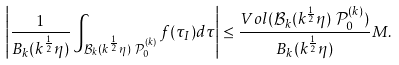Convert formula to latex. <formula><loc_0><loc_0><loc_500><loc_500>& \left | \frac { 1 } { B _ { k } ( k ^ { \frac { 1 } { 2 } } \eta ) } \int _ { \mathcal { B } _ { k } ( k ^ { \frac { 1 } { 2 } } \eta ) \ \mathcal { P } _ { 0 } ^ { ( k ) } } f ( \tau _ { I } ) d \tau \right | \leq \frac { V o l ( \mathcal { B } _ { k } ( k ^ { \frac { 1 } { 2 } } \eta ) \ \mathcal { P } _ { 0 } ^ { ( k ) } ) } { B _ { k } ( k ^ { \frac { 1 } { 2 } } \eta ) } M .</formula> 